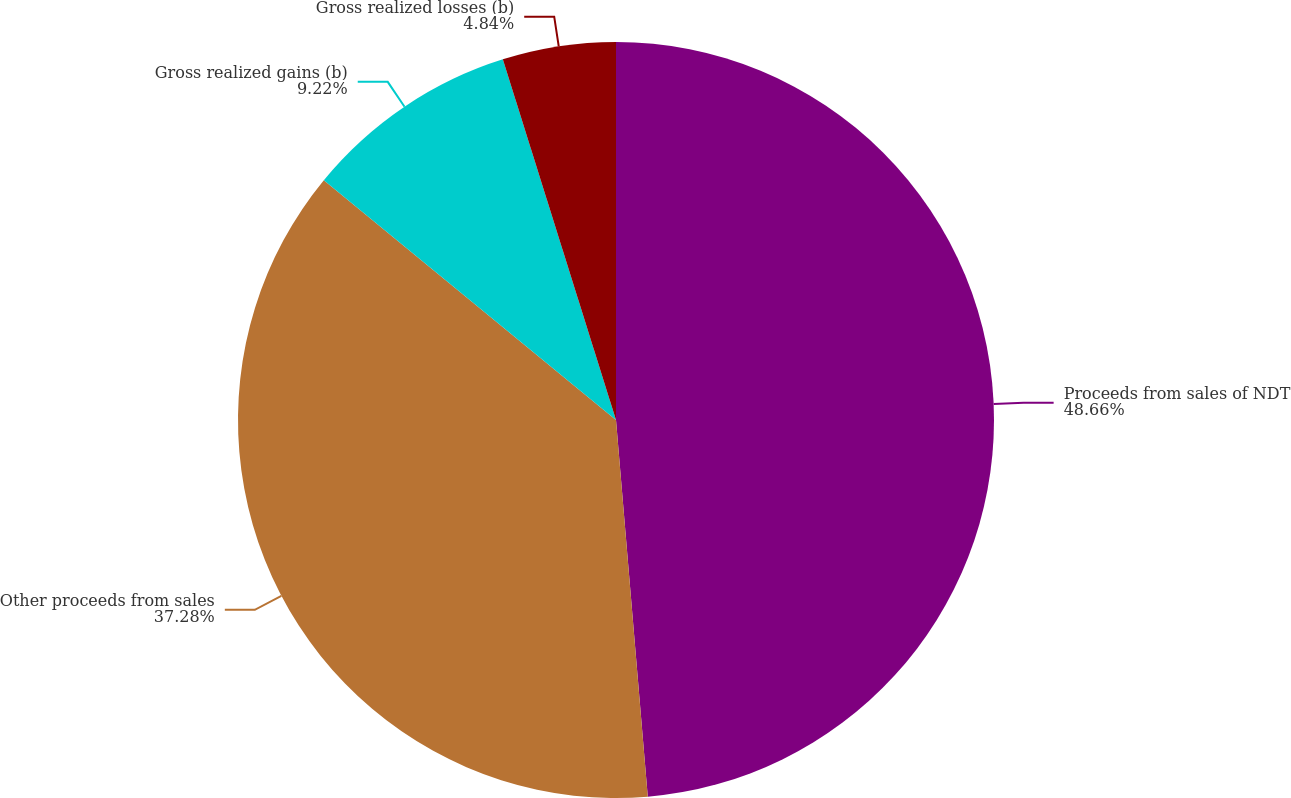Convert chart. <chart><loc_0><loc_0><loc_500><loc_500><pie_chart><fcel>Proceeds from sales of NDT<fcel>Other proceeds from sales<fcel>Gross realized gains (b)<fcel>Gross realized losses (b)<nl><fcel>48.66%<fcel>37.28%<fcel>9.22%<fcel>4.84%<nl></chart> 